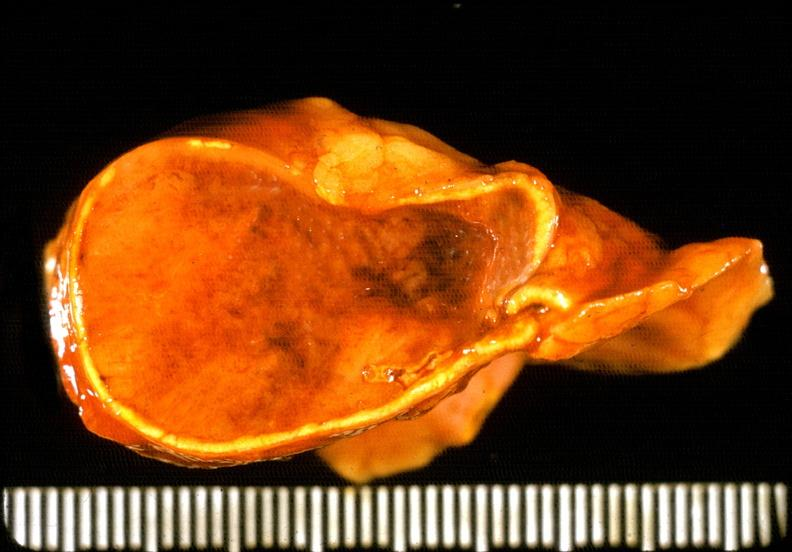where does this belong to?
Answer the question using a single word or phrase. Endocrine system 